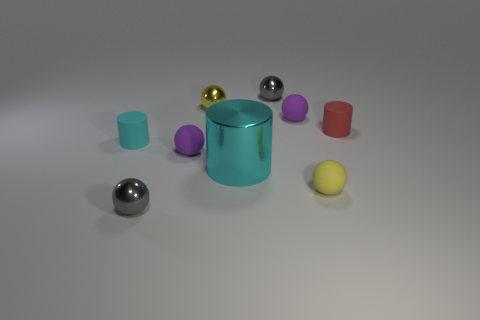There is a metallic object in front of the small yellow matte ball; is it the same size as the yellow object that is behind the tiny cyan thing?
Give a very brief answer. Yes. What is the shape of the small yellow object that is made of the same material as the red object?
Offer a terse response. Sphere. Is there any other thing that is the same shape as the cyan shiny thing?
Provide a short and direct response. Yes. What is the color of the cylinder on the right side of the small gray metallic sphere that is behind the small thing that is on the right side of the yellow matte sphere?
Make the answer very short. Red. Is the number of small red cylinders that are on the right side of the red rubber cylinder less than the number of small purple rubber balls in front of the yellow metal ball?
Provide a succinct answer. Yes. Is the big cyan metallic thing the same shape as the small yellow rubber object?
Offer a terse response. No. What number of cyan metallic cylinders have the same size as the red thing?
Give a very brief answer. 0. Are there fewer rubber spheres that are left of the large cyan metal object than blue metal cubes?
Offer a terse response. No. There is a gray shiny object behind the small gray shiny sphere in front of the tiny cyan thing; how big is it?
Your response must be concise. Small. How many things are either cylinders or tiny gray shiny balls?
Offer a terse response. 5. 